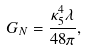<formula> <loc_0><loc_0><loc_500><loc_500>G _ { N } = \frac { \kappa _ { 5 } ^ { 4 } \lambda } { 4 8 \pi } ,</formula> 